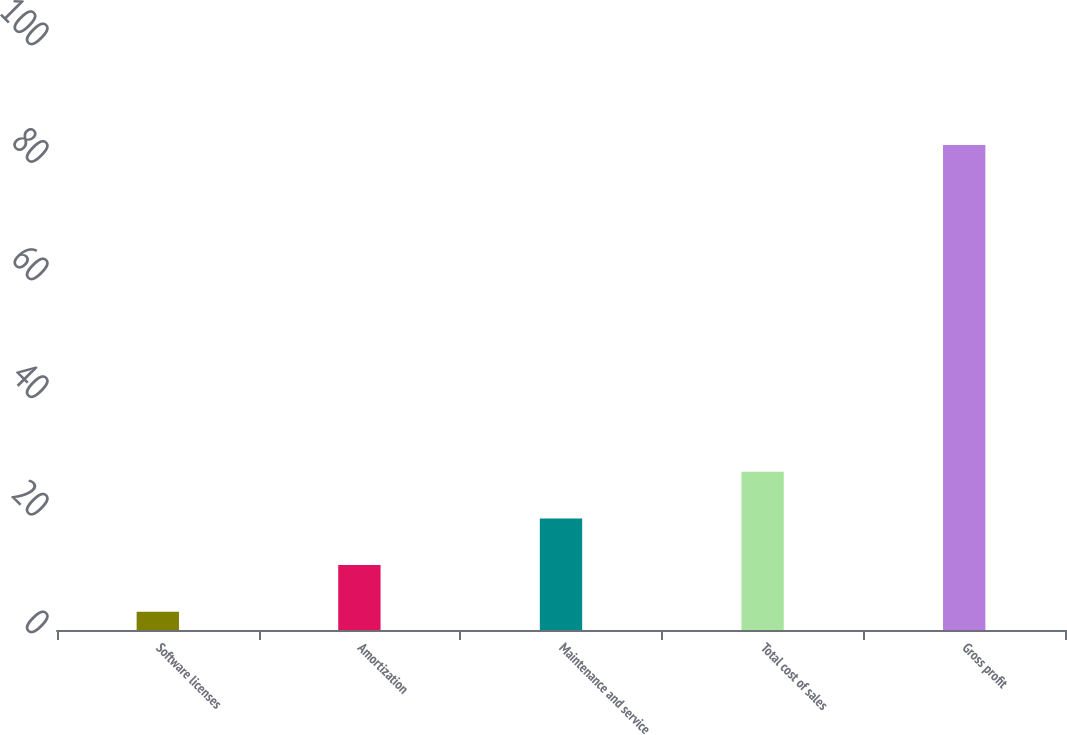Convert chart. <chart><loc_0><loc_0><loc_500><loc_500><bar_chart><fcel>Software licenses<fcel>Amortization<fcel>Maintenance and service<fcel>Total cost of sales<fcel>Gross profit<nl><fcel>3.1<fcel>11.04<fcel>18.98<fcel>26.92<fcel>82.5<nl></chart> 